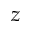Convert formula to latex. <formula><loc_0><loc_0><loc_500><loc_500>z</formula> 